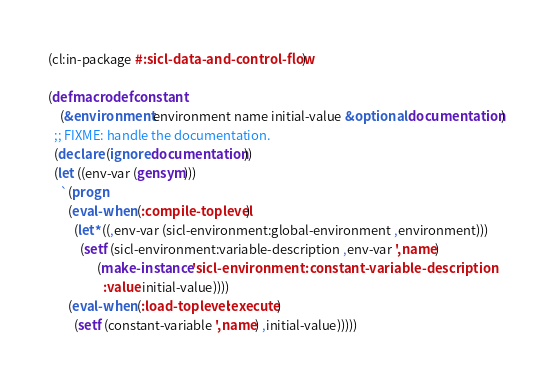Convert code to text. <code><loc_0><loc_0><loc_500><loc_500><_Lisp_>(cl:in-package #:sicl-data-and-control-flow)

(defmacro defconstant
    (&environment environment name initial-value &optional documentation)
  ;; FIXME: handle the documentation.
  (declare (ignore documentation))
  (let ((env-var (gensym)))
    `(progn
       (eval-when (:compile-toplevel)
         (let* ((,env-var (sicl-environment:global-environment ,environment)))
           (setf (sicl-environment:variable-description ,env-var ',name)
                 (make-instance 'sicl-environment:constant-variable-description
                   :value initial-value))))
       (eval-when (:load-toplevel :execute)
         (setf (constant-variable ',name) ,initial-value)))))
</code> 